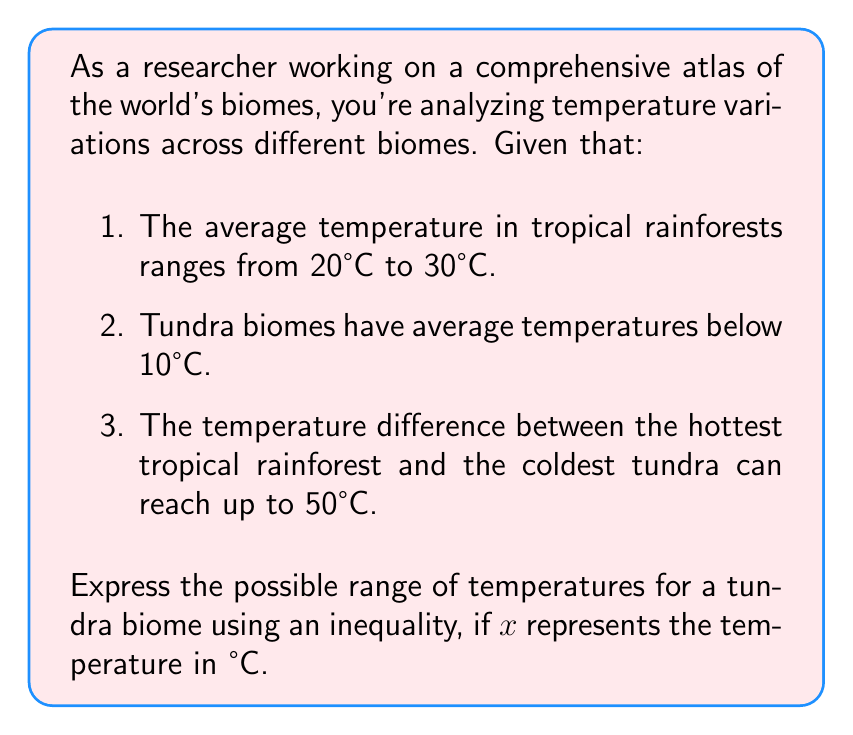Help me with this question. Let's approach this step-by-step:

1) First, we know that tundra biomes have average temperatures below 10°C. This gives us our first inequality:

   $x < 10$

2) Now, we need to consider the lower bound. We know that the temperature difference between the hottest tropical rainforest and the coldest tundra can reach up to 50°C.

3) The hottest tropical rainforest is 30°C (the upper limit of the tropical rainforest range).

4) So, we can set up an equation:

   $30 - \text{coldest tundra} \leq 50$

5) Solving for the coldest tundra:

   $-\text{coldest tundra} \leq 20$
   $\text{coldest tundra} \geq -20$

6) Therefore, the lower bound for the tundra temperature is -20°C.

7) Combining this with our earlier inequality, we get:

   $-20 \leq x < 10$

This inequality represents the possible range of temperatures for a tundra biome.
Answer: $-20 \leq x < 10$, where $x$ is the temperature in °C. 